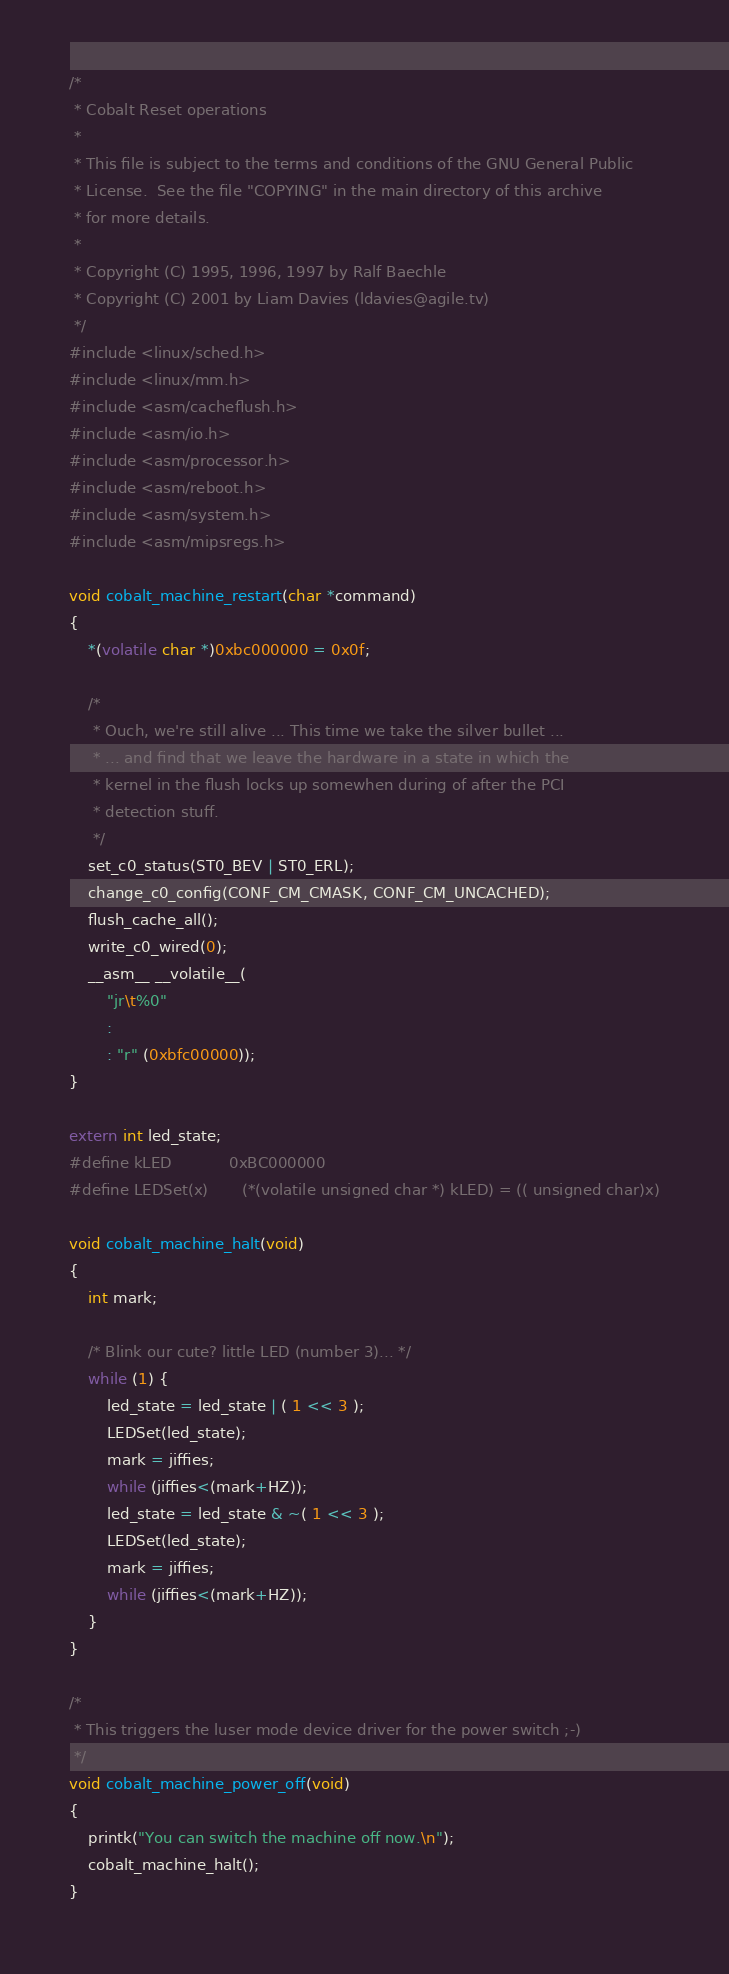Convert code to text. <code><loc_0><loc_0><loc_500><loc_500><_C_>/*
 * Cobalt Reset operations
 *
 * This file is subject to the terms and conditions of the GNU General Public
 * License.  See the file "COPYING" in the main directory of this archive
 * for more details.
 *
 * Copyright (C) 1995, 1996, 1997 by Ralf Baechle
 * Copyright (C) 2001 by Liam Davies (ldavies@agile.tv)
 */
#include <linux/sched.h>
#include <linux/mm.h>
#include <asm/cacheflush.h>
#include <asm/io.h>
#include <asm/processor.h>
#include <asm/reboot.h>
#include <asm/system.h>
#include <asm/mipsregs.h>

void cobalt_machine_restart(char *command)
{
	*(volatile char *)0xbc000000 = 0x0f;

	/*
	 * Ouch, we're still alive ... This time we take the silver bullet ...
	 * ... and find that we leave the hardware in a state in which the
	 * kernel in the flush locks up somewhen during of after the PCI
	 * detection stuff.
	 */
	set_c0_status(ST0_BEV | ST0_ERL);
	change_c0_config(CONF_CM_CMASK, CONF_CM_UNCACHED);
	flush_cache_all();
	write_c0_wired(0);
	__asm__ __volatile__(
		"jr\t%0"
		:
		: "r" (0xbfc00000));
}

extern int led_state;
#define kLED            0xBC000000
#define LEDSet(x)       (*(volatile unsigned char *) kLED) = (( unsigned char)x)

void cobalt_machine_halt(void)
{
	int mark;

	/* Blink our cute? little LED (number 3)... */
	while (1) {
		led_state = led_state | ( 1 << 3 );
		LEDSet(led_state);
		mark = jiffies;
		while (jiffies<(mark+HZ));
		led_state = led_state & ~( 1 << 3 );
		LEDSet(led_state);
		mark = jiffies;
		while (jiffies<(mark+HZ));
	}
}

/*
 * This triggers the luser mode device driver for the power switch ;-)
 */
void cobalt_machine_power_off(void)
{
	printk("You can switch the machine off now.\n");
	cobalt_machine_halt();
}
</code> 